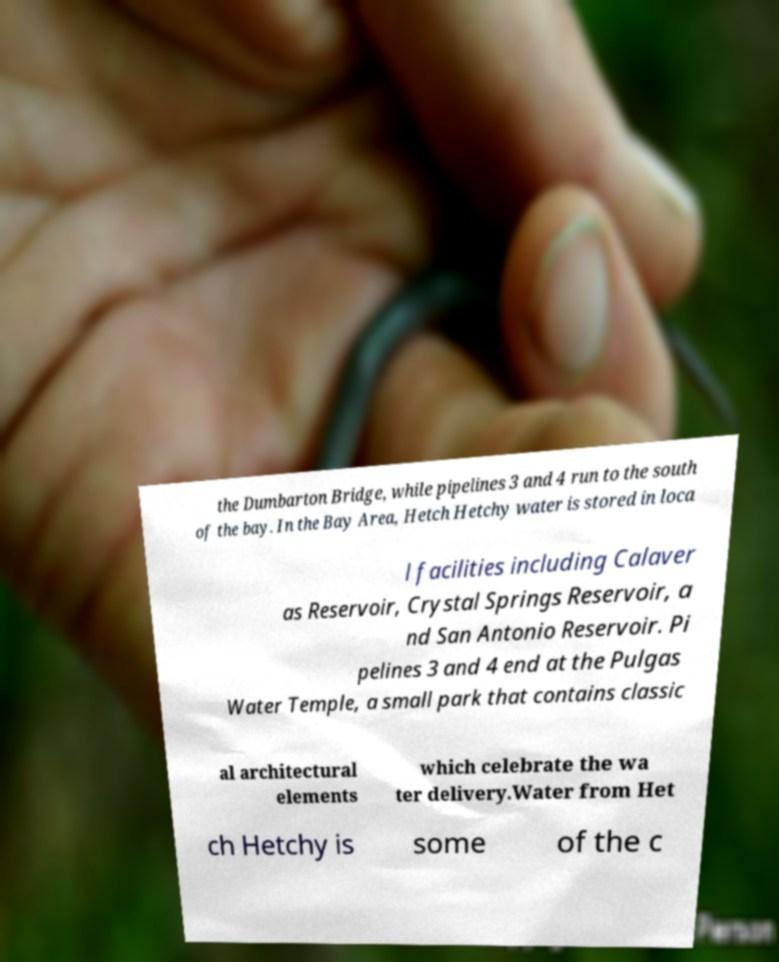Please identify and transcribe the text found in this image. the Dumbarton Bridge, while pipelines 3 and 4 run to the south of the bay. In the Bay Area, Hetch Hetchy water is stored in loca l facilities including Calaver as Reservoir, Crystal Springs Reservoir, a nd San Antonio Reservoir. Pi pelines 3 and 4 end at the Pulgas Water Temple, a small park that contains classic al architectural elements which celebrate the wa ter delivery.Water from Het ch Hetchy is some of the c 